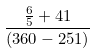Convert formula to latex. <formula><loc_0><loc_0><loc_500><loc_500>\frac { \frac { 6 } { 5 } + 4 1 } { ( 3 6 0 - 2 5 1 ) }</formula> 